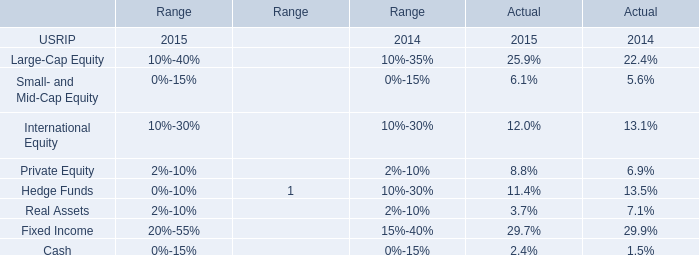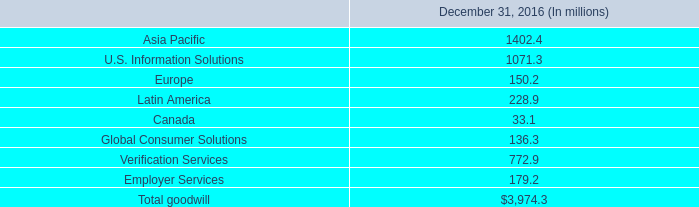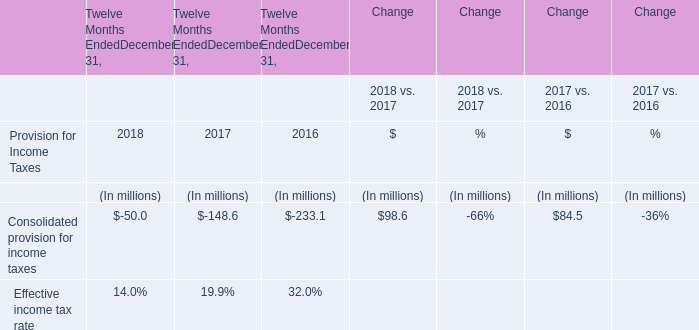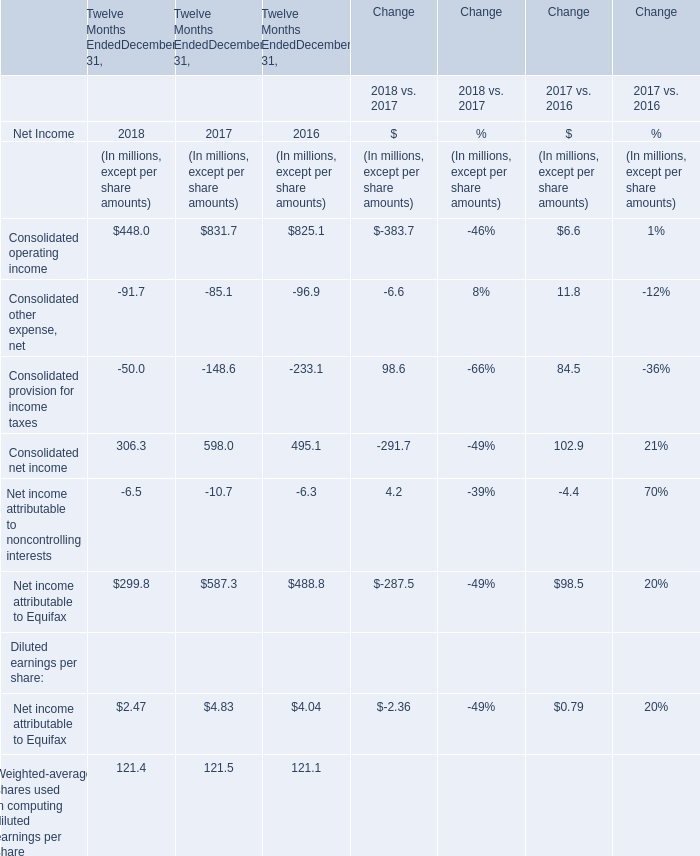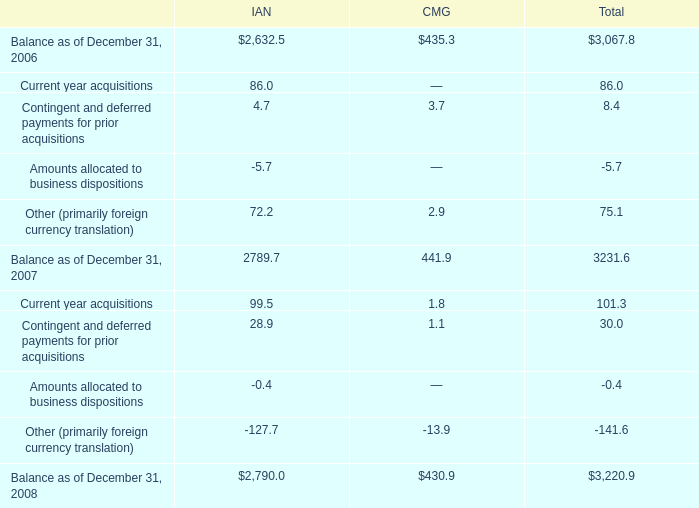what was the percentage change in total goodwill carrying value from 2006 to 2007? 
Computations: ((3231.6 - 3067.8) / 3067.8)
Answer: 0.05339. 